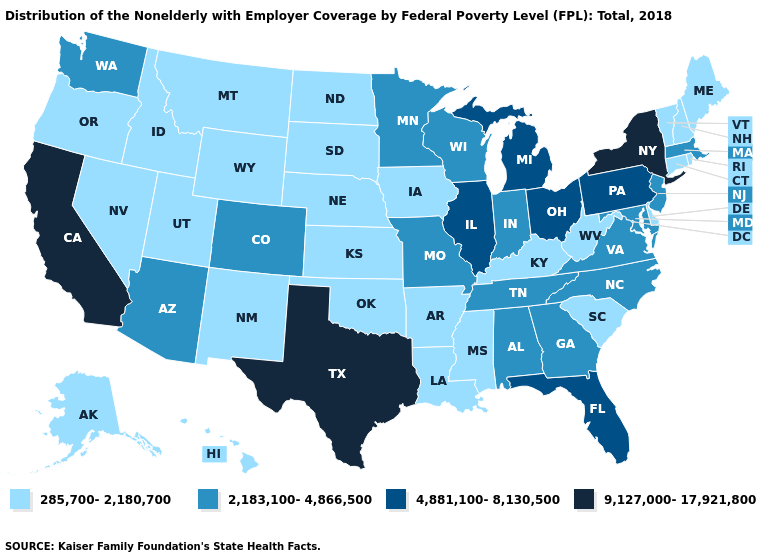What is the value of Delaware?
Keep it brief. 285,700-2,180,700. Which states have the lowest value in the USA?
Keep it brief. Alaska, Arkansas, Connecticut, Delaware, Hawaii, Idaho, Iowa, Kansas, Kentucky, Louisiana, Maine, Mississippi, Montana, Nebraska, Nevada, New Hampshire, New Mexico, North Dakota, Oklahoma, Oregon, Rhode Island, South Carolina, South Dakota, Utah, Vermont, West Virginia, Wyoming. Name the states that have a value in the range 9,127,000-17,921,800?
Answer briefly. California, New York, Texas. Among the states that border Virginia , which have the lowest value?
Write a very short answer. Kentucky, West Virginia. Does Georgia have the lowest value in the South?
Give a very brief answer. No. What is the value of Illinois?
Quick response, please. 4,881,100-8,130,500. Name the states that have a value in the range 4,881,100-8,130,500?
Write a very short answer. Florida, Illinois, Michigan, Ohio, Pennsylvania. Name the states that have a value in the range 2,183,100-4,866,500?
Be succinct. Alabama, Arizona, Colorado, Georgia, Indiana, Maryland, Massachusetts, Minnesota, Missouri, New Jersey, North Carolina, Tennessee, Virginia, Washington, Wisconsin. What is the lowest value in states that border North Dakota?
Keep it brief. 285,700-2,180,700. What is the highest value in the Northeast ?
Concise answer only. 9,127,000-17,921,800. What is the lowest value in states that border South Dakota?
Concise answer only. 285,700-2,180,700. Which states have the lowest value in the South?
Short answer required. Arkansas, Delaware, Kentucky, Louisiana, Mississippi, Oklahoma, South Carolina, West Virginia. Does the first symbol in the legend represent the smallest category?
Concise answer only. Yes. What is the lowest value in the USA?
Concise answer only. 285,700-2,180,700. Among the states that border Arkansas , which have the lowest value?
Write a very short answer. Louisiana, Mississippi, Oklahoma. 